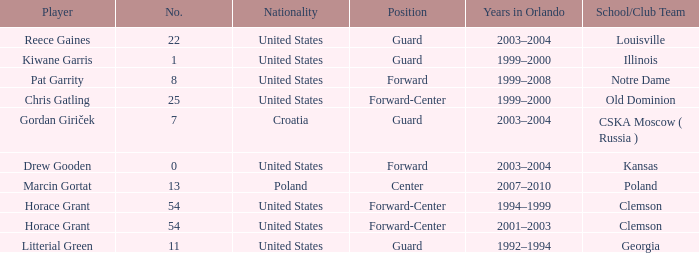What is the number associated with chris gatling? 25.0. 